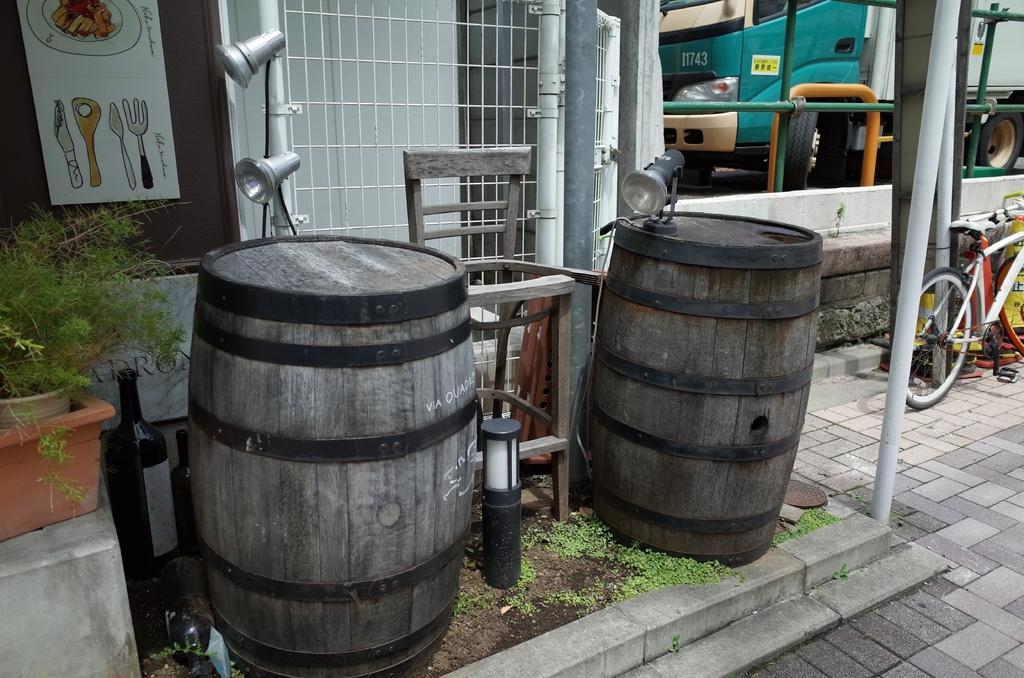Describe this image in one or two sentences. Here in this picture we can see two barrels present on the ground, which is covered with grass over there and in the middle we can see a wooden chair present and we can see some bottles behind it and we can also see lights present on the pole over there and on the left side we can see a plant present and on the wall we can see a poster present and on right side we can see a bus present and we can see a gate, a railing and a bicycle present over there. 